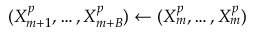Convert formula to latex. <formula><loc_0><loc_0><loc_500><loc_500>( X _ { m + 1 } ^ { p } , \hdots , X _ { m + B } ^ { p } ) \gets ( X _ { m } ^ { p } , \hdots , X _ { m } ^ { p } )</formula> 